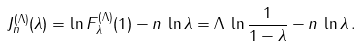Convert formula to latex. <formula><loc_0><loc_0><loc_500><loc_500>J _ { n } ^ { ( \Lambda ) } ( \lambda ) = \ln F _ { \lambda } ^ { ( \Lambda ) } ( 1 ) - n \, \ln \lambda = \Lambda \, \ln \frac { 1 } { 1 - \lambda } - n \, \ln \lambda \, .</formula> 